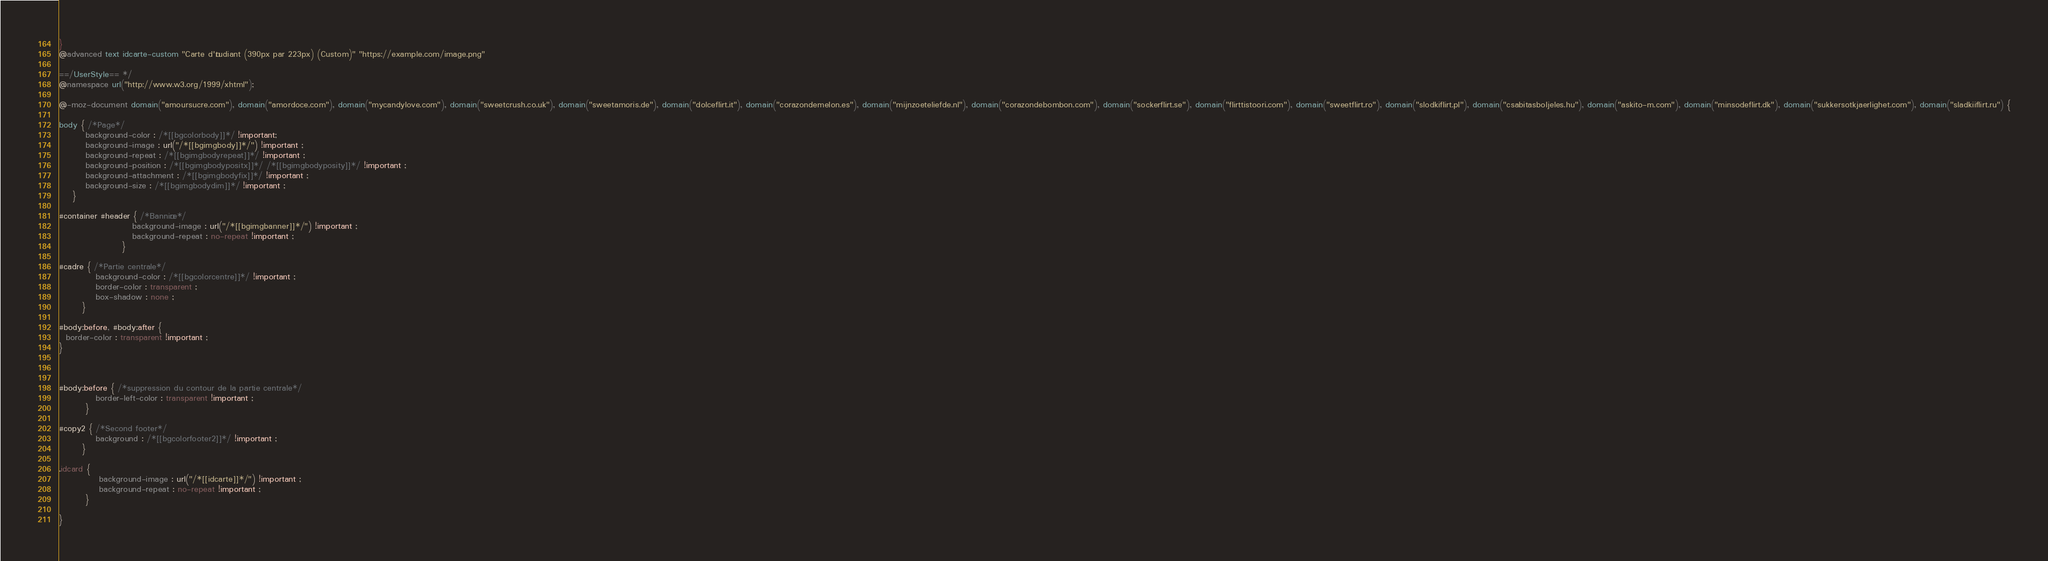<code> <loc_0><loc_0><loc_500><loc_500><_CSS_>}
@advanced text idcarte-custom "Carte d'étudiant (390px par 223px) (Custom)" "https://example.com/image.png"

==/UserStyle== */
@namespace url("http://www.w3.org/1999/xhtml");

@-moz-document domain("amoursucre.com"), domain("amordoce.com"), domain("mycandylove.com"), domain("sweetcrush.co.uk"), domain("sweetamoris.de"), domain("dolceflirt.it"), domain("corazondemelon.es"), domain("mijnzoeteliefde.nl"), domain("corazondebombon.com"), domain("sockerflirt.se"), domain("flirttistoori.com"), domain("sweetflirt.ro"), domain("slodkiflirt.pl"), domain("csabitasboljeles.hu"), domain("askito-m.com"), domain("minsodeflirt.dk"), domain("sukkersotkjaerlighet.com"), domain("sladkiiflirt.ru") {

body { /*Page*/
        background-color : /*[[bgcolorbody]]*/ !important;
        background-image : url("/*[[bgimgbody]]*/") !important ;
        background-repeat : /*[[bgimgbodyrepeat]]*/ !important ;
        background-position : /*[[bgimgbodypositx]]*/ /*[[bgimgbodyposity]]*/ !important ;
        background-attachment : /*[[bgimgbodyfix]]*/ !important ;
        background-size : /*[[bgimgbodydim]]*/ !important ;
    }

#container #header { /*Bannière*/
                      background-image : url("/*[[bgimgbanner]]*/") !important ;
                      background-repeat : no-repeat !important ;
                   }
    
#cadre { /*Partie centrale*/
           background-color : /*[[bgcolorcentre]]*/ !important ;
           border-color : transparent ;
           box-shadow : none ;
       }

#body:before, #body:after {
  border-color : transparent !important ;
}


    
#body:before { /*suppression du contour de la partie centrale*/
           border-left-color : transparent !important ;
        }

#copy2 { /*Second footer*/
           background : /*[[bgcolorfooter2]]*/ !important ;
       }

.idcard {
            background-image : url("/*[[idcarte]]*/") !important ;
            background-repeat : no-repeat !important ;
        }
    
}</code> 